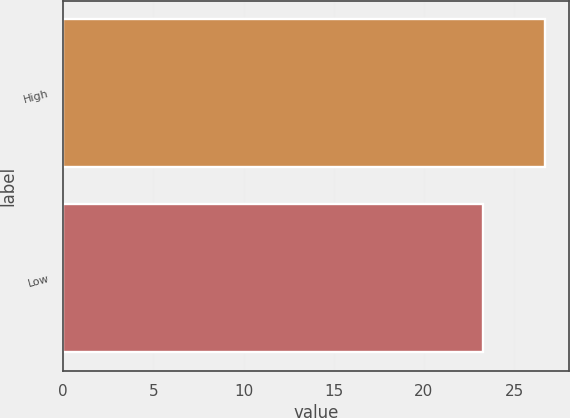<chart> <loc_0><loc_0><loc_500><loc_500><bar_chart><fcel>High<fcel>Low<nl><fcel>26.69<fcel>23.28<nl></chart> 